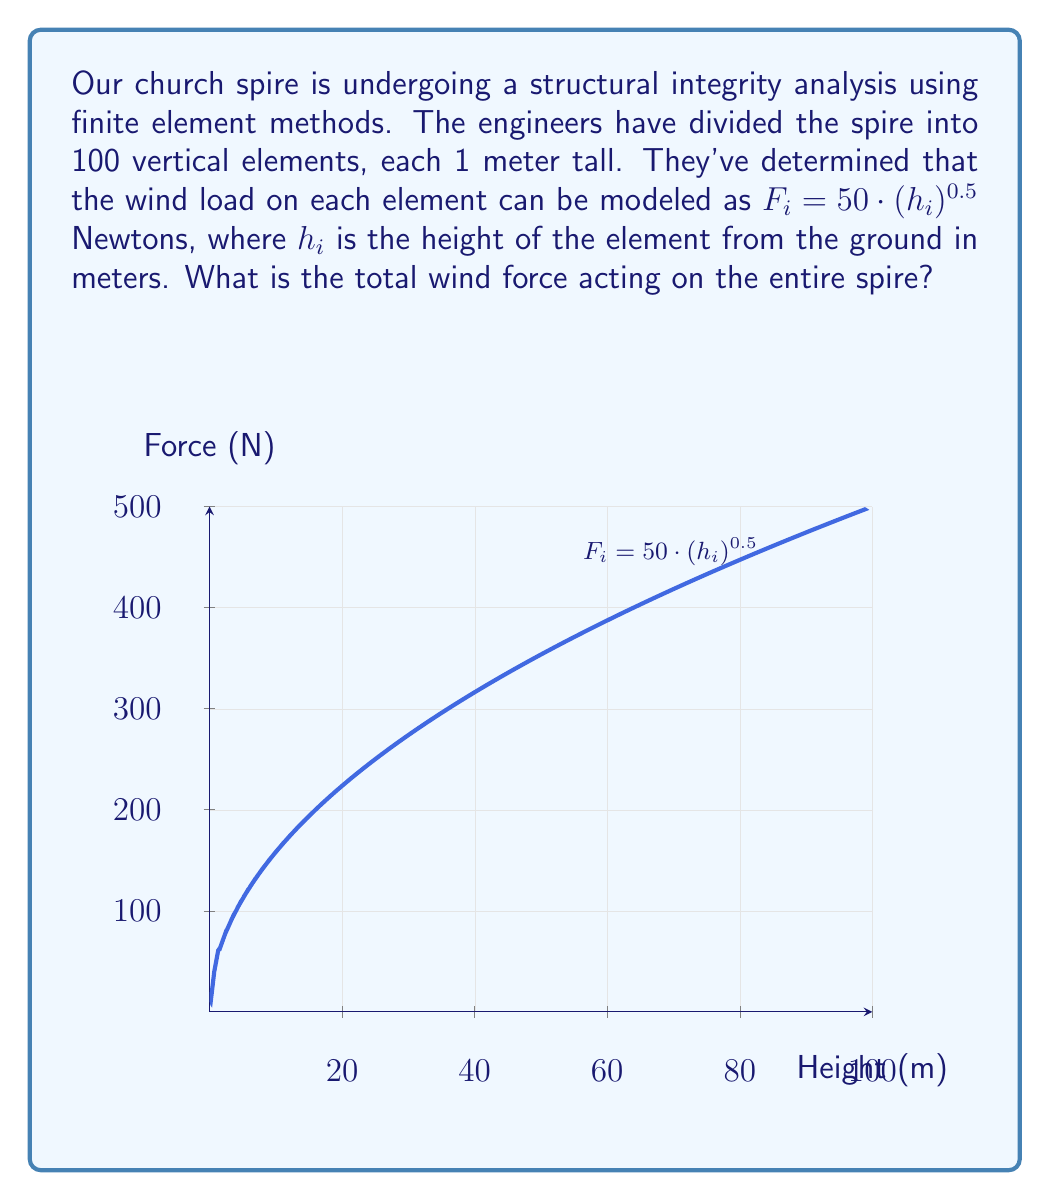Solve this math problem. Let's approach this step-by-step:

1) We need to calculate the force on each element and then sum these forces.

2) The height of the i-th element from the ground can be expressed as:
   $h_i = i - 0.5$ (meters)
   This is because the midpoint of each 1-meter element is 0.5 meters less than its top.

3) The force on the i-th element is:
   $F_i = 50 \cdot (h_i)^{0.5} = 50 \cdot (i - 0.5)^{0.5}$

4) The total force is the sum of forces on all elements:
   $$F_{total} = \sum_{i=1}^{100} 50 \cdot (i - 0.5)^{0.5}$$

5) This sum can be calculated as:
   $$F_{total} = 50 \cdot \sum_{i=1}^{100} (i - 0.5)^{0.5}$$

6) While we could calculate this sum directly, it's more efficient to use an approximation. The sum of square roots follows this formula:
   $$\sum_{i=1}^{n} \sqrt{i} \approx \frac{2}{3}n^{3/2} + \frac{1}{2}n^{1/2}$$

7) In our case, we're summing $(i - 0.5)^{0.5}$ from 1 to 100, which is equivalent to summing $\sqrt{i}$ from 0.5 to 99.5. So we can use n = 99.5 in our formula:

   $$F_{total} \approx 50 \cdot (\frac{2}{3}(99.5)^{3/2} + \frac{1}{2}(99.5)^{1/2})$$

8) Calculating this:
   $$F_{total} \approx 50 \cdot (661.33 + 4.98) \approx 33,315.5 \text{ N}$$

Therefore, the total wind force acting on the entire spire is approximately 33,316 Newtons.
Answer: 33,316 N 